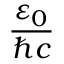<formula> <loc_0><loc_0><loc_500><loc_500>\frac { \varepsilon _ { 0 } } { \hbar { c } }</formula> 